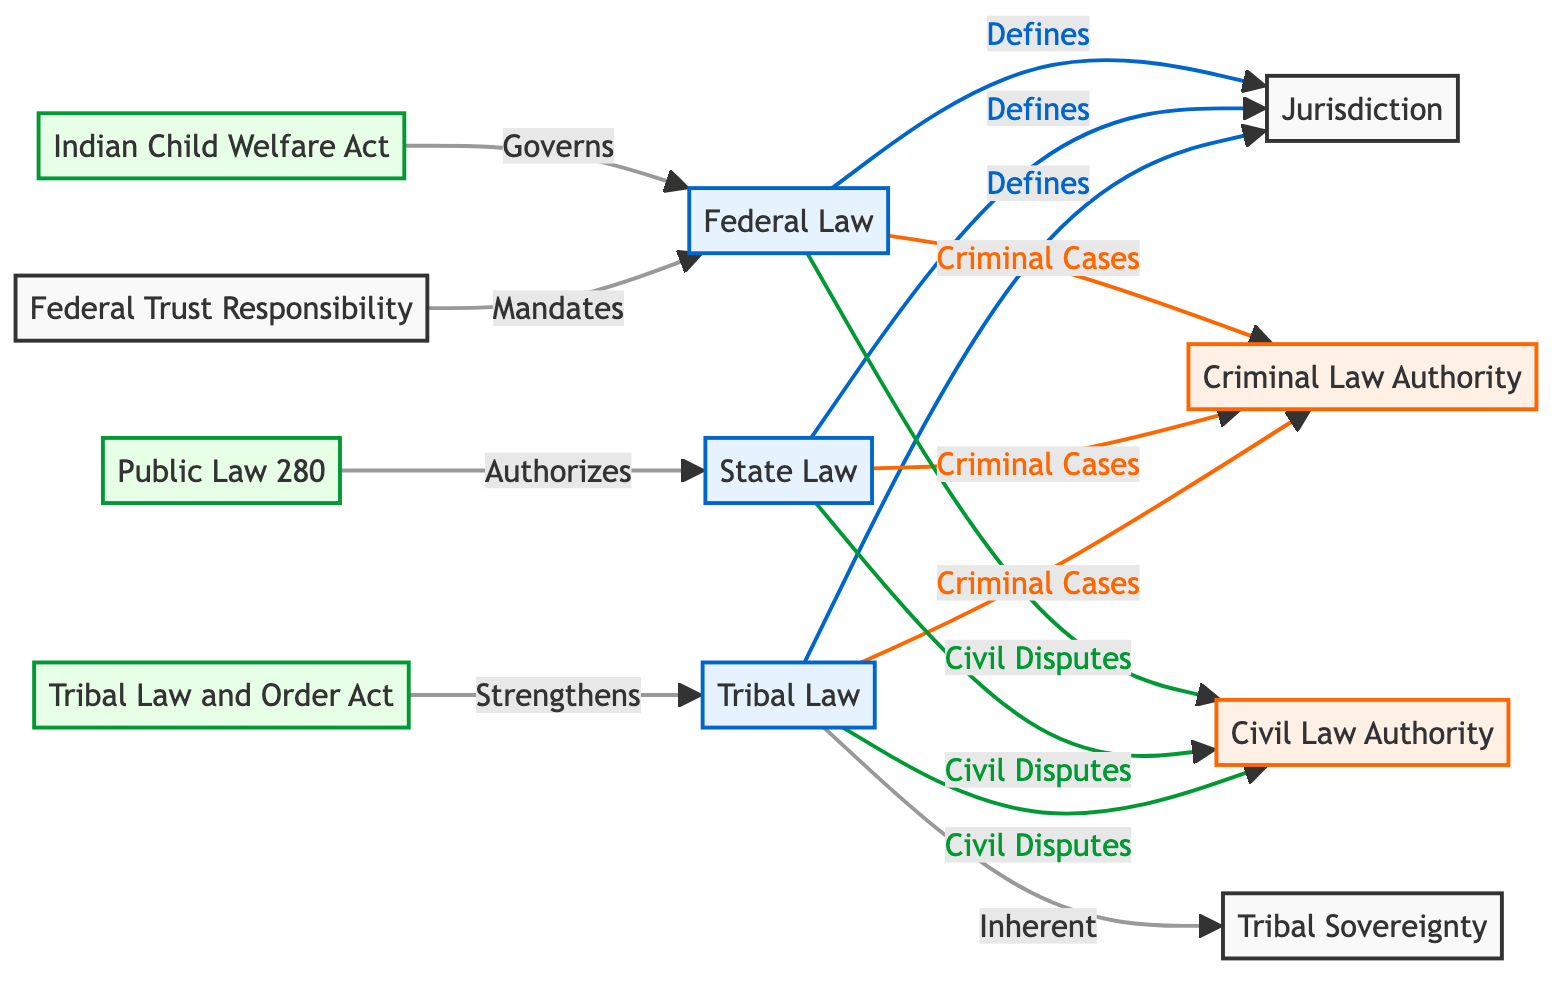What are the three main types of law depicted in this diagram? The three main types of law shown in the diagram are Tribal Law, State Law, and Federal Law. These are separate nodes identified in the diagram that contribute to jurisdictional authority.
Answer: Tribal Law, State Law, Federal Law How many authorities related to jurisdiction are specified in the diagram? There are two types of authorities specified related to jurisdiction: Criminal Law Authority and Civil Law Authority, identified as separate nodes in the diagram under the jurisdiction node.
Answer: 2 Which law directly strengthens Tribal Law according to the diagram? The Tribal Law and Order Act is indicated in the diagram as the law that strengthens Tribal Law. This law is connected to the Tribal Law node, signifying its supportive relationship.
Answer: Tribal Law and Order Act What does Public Law 280 authorize? Public Law 280 is depicted in the diagram as authorizing State Law. It is a directed connection from Public Law 280 to State Law, showing that it gives state jurisdiction over certain matters within tribal lands.
Answer: State Law Which law governs federal law related to child welfare matters as illustrated in the diagram? The Indian Child Welfare Act is the law that governs federal law related to child welfare matters, as shown by its connection to the Federal Law node in the diagram.
Answer: Indian Child Welfare Act What type of disputes do Tribal Law, State Law, and Federal Law all share in the diagram? All three types of law share Civil Disputes, as depicted by the link from each law type to the Civil Law Authority node. This indicates that they have jurisdiction in civil matters.
Answer: Civil Disputes What authority is specifically tied to tribal sovereignty in the diagram? The authority tied to tribal sovereignty is inherent authority, as depicted under the Tribal Law connection. This reflects the acknowledgment of tribes' self-governance within their jurisdictions.
Answer: Inherent Which law mandates federal law within the jurisdictional structure shown? Federal Trust Responsibility is the law that mandates Federal Law according to the diagram. This connection reflects the obligation of federal authorities in tribal governance matters.
Answer: Federal Trust Responsibility 